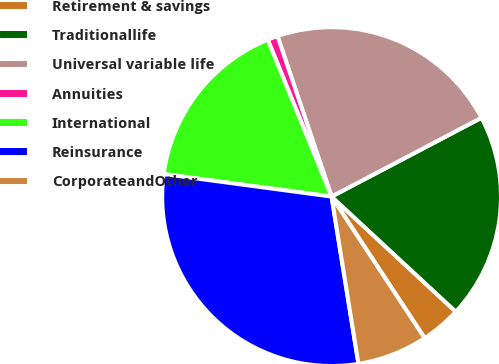Convert chart. <chart><loc_0><loc_0><loc_500><loc_500><pie_chart><fcel>Retirement & savings<fcel>Traditionallife<fcel>Universal variable life<fcel>Annuities<fcel>International<fcel>Reinsurance<fcel>CorporateandOther<nl><fcel>3.85%<fcel>19.6%<fcel>22.47%<fcel>0.98%<fcel>16.73%<fcel>29.66%<fcel>6.72%<nl></chart> 